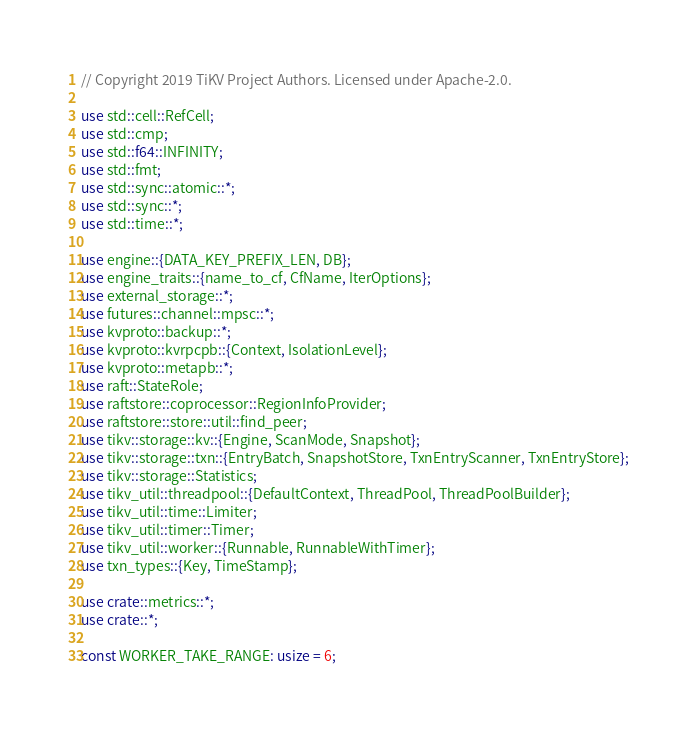<code> <loc_0><loc_0><loc_500><loc_500><_Rust_>// Copyright 2019 TiKV Project Authors. Licensed under Apache-2.0.

use std::cell::RefCell;
use std::cmp;
use std::f64::INFINITY;
use std::fmt;
use std::sync::atomic::*;
use std::sync::*;
use std::time::*;

use engine::{DATA_KEY_PREFIX_LEN, DB};
use engine_traits::{name_to_cf, CfName, IterOptions};
use external_storage::*;
use futures::channel::mpsc::*;
use kvproto::backup::*;
use kvproto::kvrpcpb::{Context, IsolationLevel};
use kvproto::metapb::*;
use raft::StateRole;
use raftstore::coprocessor::RegionInfoProvider;
use raftstore::store::util::find_peer;
use tikv::storage::kv::{Engine, ScanMode, Snapshot};
use tikv::storage::txn::{EntryBatch, SnapshotStore, TxnEntryScanner, TxnEntryStore};
use tikv::storage::Statistics;
use tikv_util::threadpool::{DefaultContext, ThreadPool, ThreadPoolBuilder};
use tikv_util::time::Limiter;
use tikv_util::timer::Timer;
use tikv_util::worker::{Runnable, RunnableWithTimer};
use txn_types::{Key, TimeStamp};

use crate::metrics::*;
use crate::*;

const WORKER_TAKE_RANGE: usize = 6;</code> 